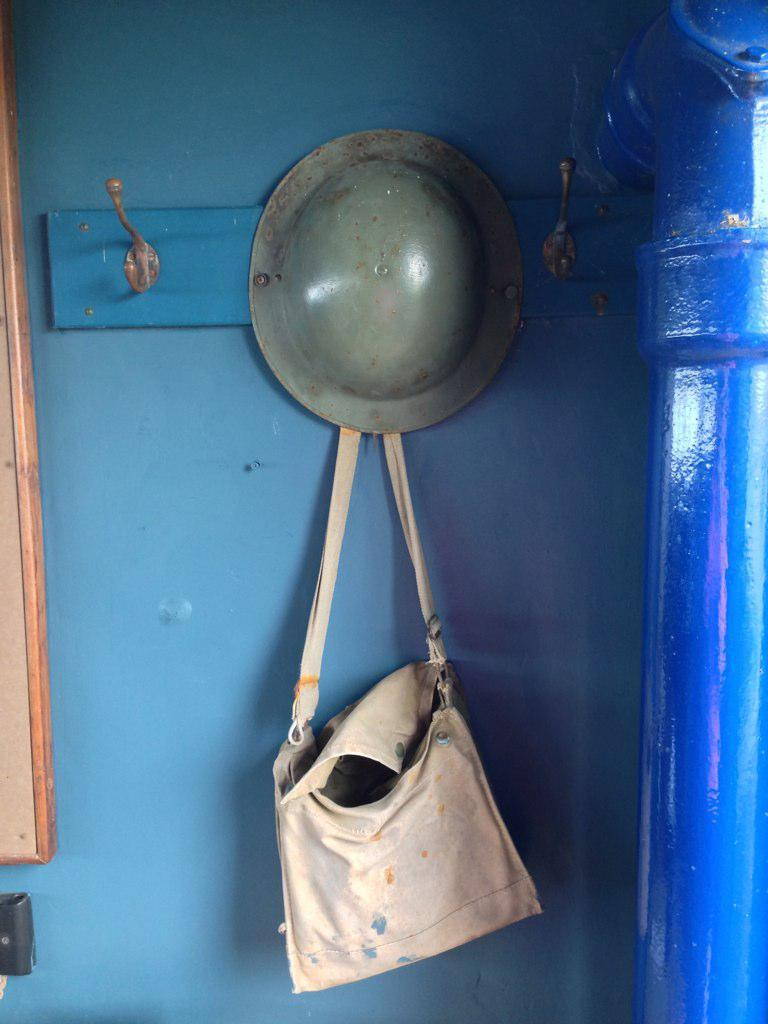What is hanging on the hanger in the image? There is a hat and a bag on a hanger in the image. Can you describe the hat on the hanger? The hat is hanging on the hanger, but no specific details about its appearance are provided. What else is hanging on the hanger besides the hat? There is a bag hanging on the hanger as well. What type of harmony is being played by the fowl in the image? There are no fowl or musical instruments present in the image, so it is not possible to determine if any harmony is being played. 